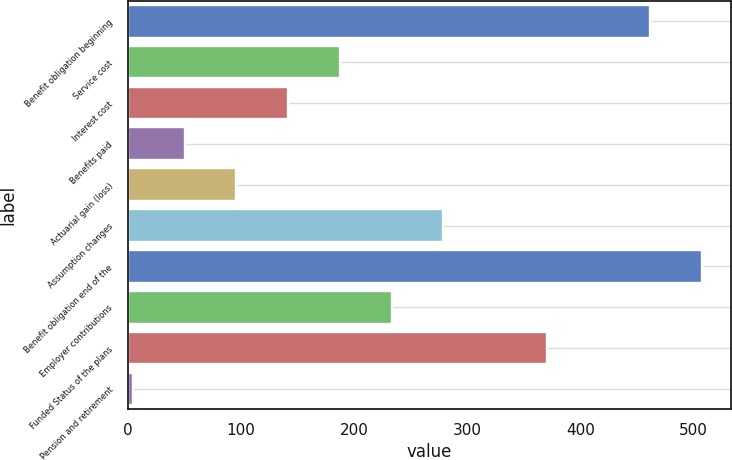Convert chart. <chart><loc_0><loc_0><loc_500><loc_500><bar_chart><fcel>Benefit obligation beginning<fcel>Service cost<fcel>Interest cost<fcel>Benefits paid<fcel>Actuarial gain (loss)<fcel>Assumption changes<fcel>Benefit obligation end of the<fcel>Employer contributions<fcel>Funded Status of the plans<fcel>Pension and retirement<nl><fcel>461.8<fcel>187.3<fcel>141.55<fcel>50.05<fcel>95.8<fcel>278.8<fcel>507.55<fcel>233.05<fcel>370.3<fcel>4.3<nl></chart> 